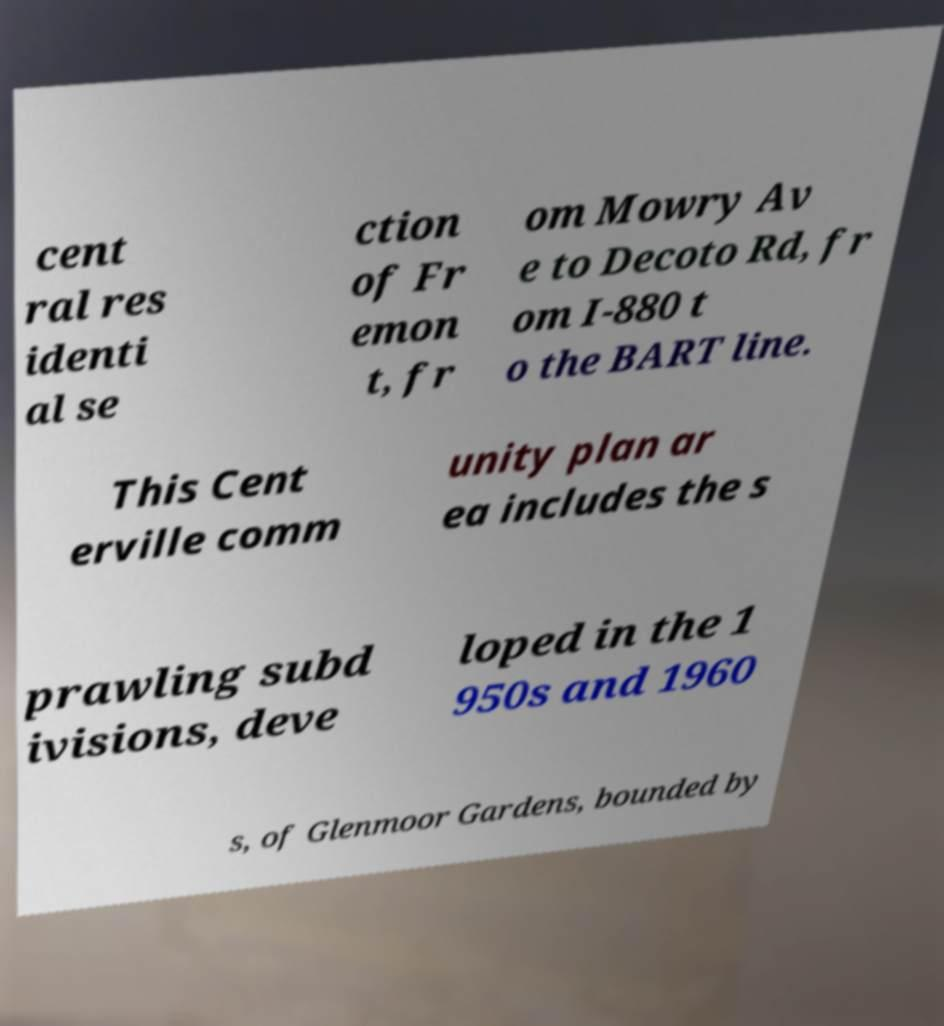I need the written content from this picture converted into text. Can you do that? cent ral res identi al se ction of Fr emon t, fr om Mowry Av e to Decoto Rd, fr om I-880 t o the BART line. This Cent erville comm unity plan ar ea includes the s prawling subd ivisions, deve loped in the 1 950s and 1960 s, of Glenmoor Gardens, bounded by 